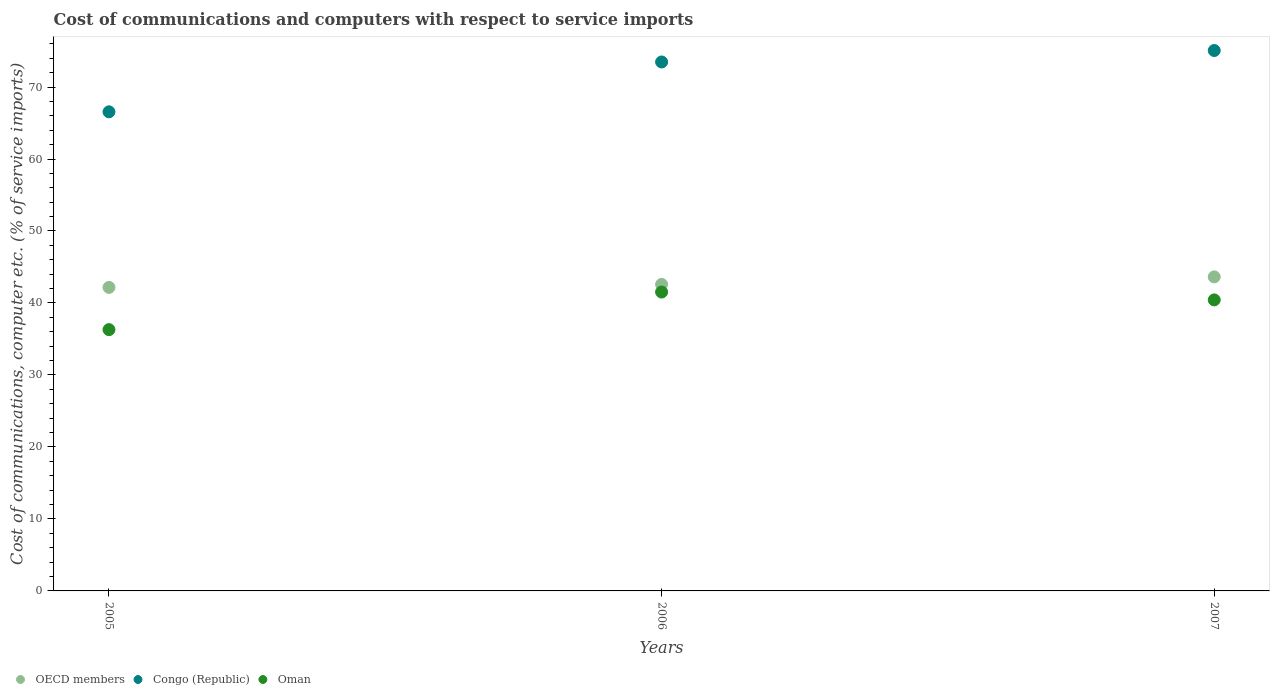How many different coloured dotlines are there?
Your answer should be very brief. 3. Is the number of dotlines equal to the number of legend labels?
Your answer should be very brief. Yes. What is the cost of communications and computers in Congo (Republic) in 2007?
Make the answer very short. 75.07. Across all years, what is the maximum cost of communications and computers in Oman?
Offer a terse response. 41.52. Across all years, what is the minimum cost of communications and computers in Oman?
Your response must be concise. 36.3. What is the total cost of communications and computers in OECD members in the graph?
Offer a terse response. 128.37. What is the difference between the cost of communications and computers in Oman in 2006 and that in 2007?
Keep it short and to the point. 1.09. What is the difference between the cost of communications and computers in Oman in 2006 and the cost of communications and computers in OECD members in 2007?
Offer a very short reply. -2.11. What is the average cost of communications and computers in OECD members per year?
Offer a terse response. 42.79. In the year 2005, what is the difference between the cost of communications and computers in Congo (Republic) and cost of communications and computers in Oman?
Your answer should be very brief. 30.26. What is the ratio of the cost of communications and computers in Congo (Republic) in 2005 to that in 2007?
Ensure brevity in your answer.  0.89. Is the cost of communications and computers in Oman in 2006 less than that in 2007?
Provide a short and direct response. No. Is the difference between the cost of communications and computers in Congo (Republic) in 2005 and 2007 greater than the difference between the cost of communications and computers in Oman in 2005 and 2007?
Offer a terse response. No. What is the difference between the highest and the second highest cost of communications and computers in OECD members?
Provide a succinct answer. 1.04. What is the difference between the highest and the lowest cost of communications and computers in Congo (Republic)?
Your answer should be compact. 8.51. Is the sum of the cost of communications and computers in Congo (Republic) in 2005 and 2007 greater than the maximum cost of communications and computers in OECD members across all years?
Give a very brief answer. Yes. Is the cost of communications and computers in OECD members strictly greater than the cost of communications and computers in Oman over the years?
Your answer should be compact. Yes. How many dotlines are there?
Your response must be concise. 3. How many years are there in the graph?
Your response must be concise. 3. Does the graph contain any zero values?
Offer a very short reply. No. Does the graph contain grids?
Make the answer very short. No. How are the legend labels stacked?
Make the answer very short. Horizontal. What is the title of the graph?
Keep it short and to the point. Cost of communications and computers with respect to service imports. What is the label or title of the X-axis?
Your response must be concise. Years. What is the label or title of the Y-axis?
Provide a short and direct response. Cost of communications, computer etc. (% of service imports). What is the Cost of communications, computer etc. (% of service imports) of OECD members in 2005?
Provide a succinct answer. 42.17. What is the Cost of communications, computer etc. (% of service imports) of Congo (Republic) in 2005?
Your answer should be compact. 66.56. What is the Cost of communications, computer etc. (% of service imports) in Oman in 2005?
Ensure brevity in your answer.  36.3. What is the Cost of communications, computer etc. (% of service imports) of OECD members in 2006?
Your answer should be very brief. 42.58. What is the Cost of communications, computer etc. (% of service imports) of Congo (Republic) in 2006?
Make the answer very short. 73.48. What is the Cost of communications, computer etc. (% of service imports) in Oman in 2006?
Your answer should be very brief. 41.52. What is the Cost of communications, computer etc. (% of service imports) in OECD members in 2007?
Provide a short and direct response. 43.63. What is the Cost of communications, computer etc. (% of service imports) of Congo (Republic) in 2007?
Your response must be concise. 75.07. What is the Cost of communications, computer etc. (% of service imports) of Oman in 2007?
Keep it short and to the point. 40.43. Across all years, what is the maximum Cost of communications, computer etc. (% of service imports) in OECD members?
Offer a terse response. 43.63. Across all years, what is the maximum Cost of communications, computer etc. (% of service imports) of Congo (Republic)?
Ensure brevity in your answer.  75.07. Across all years, what is the maximum Cost of communications, computer etc. (% of service imports) in Oman?
Provide a succinct answer. 41.52. Across all years, what is the minimum Cost of communications, computer etc. (% of service imports) of OECD members?
Your answer should be very brief. 42.17. Across all years, what is the minimum Cost of communications, computer etc. (% of service imports) in Congo (Republic)?
Your answer should be compact. 66.56. Across all years, what is the minimum Cost of communications, computer etc. (% of service imports) in Oman?
Give a very brief answer. 36.3. What is the total Cost of communications, computer etc. (% of service imports) in OECD members in the graph?
Ensure brevity in your answer.  128.37. What is the total Cost of communications, computer etc. (% of service imports) in Congo (Republic) in the graph?
Keep it short and to the point. 215.11. What is the total Cost of communications, computer etc. (% of service imports) in Oman in the graph?
Offer a terse response. 118.24. What is the difference between the Cost of communications, computer etc. (% of service imports) in OECD members in 2005 and that in 2006?
Ensure brevity in your answer.  -0.42. What is the difference between the Cost of communications, computer etc. (% of service imports) of Congo (Republic) in 2005 and that in 2006?
Give a very brief answer. -6.93. What is the difference between the Cost of communications, computer etc. (% of service imports) of Oman in 2005 and that in 2006?
Your answer should be compact. -5.22. What is the difference between the Cost of communications, computer etc. (% of service imports) of OECD members in 2005 and that in 2007?
Ensure brevity in your answer.  -1.46. What is the difference between the Cost of communications, computer etc. (% of service imports) of Congo (Republic) in 2005 and that in 2007?
Your answer should be compact. -8.51. What is the difference between the Cost of communications, computer etc. (% of service imports) in Oman in 2005 and that in 2007?
Offer a very short reply. -4.13. What is the difference between the Cost of communications, computer etc. (% of service imports) in OECD members in 2006 and that in 2007?
Make the answer very short. -1.04. What is the difference between the Cost of communications, computer etc. (% of service imports) in Congo (Republic) in 2006 and that in 2007?
Offer a very short reply. -1.59. What is the difference between the Cost of communications, computer etc. (% of service imports) of Oman in 2006 and that in 2007?
Give a very brief answer. 1.09. What is the difference between the Cost of communications, computer etc. (% of service imports) in OECD members in 2005 and the Cost of communications, computer etc. (% of service imports) in Congo (Republic) in 2006?
Ensure brevity in your answer.  -31.32. What is the difference between the Cost of communications, computer etc. (% of service imports) of OECD members in 2005 and the Cost of communications, computer etc. (% of service imports) of Oman in 2006?
Provide a succinct answer. 0.65. What is the difference between the Cost of communications, computer etc. (% of service imports) in Congo (Republic) in 2005 and the Cost of communications, computer etc. (% of service imports) in Oman in 2006?
Give a very brief answer. 25.04. What is the difference between the Cost of communications, computer etc. (% of service imports) of OECD members in 2005 and the Cost of communications, computer etc. (% of service imports) of Congo (Republic) in 2007?
Your response must be concise. -32.9. What is the difference between the Cost of communications, computer etc. (% of service imports) of OECD members in 2005 and the Cost of communications, computer etc. (% of service imports) of Oman in 2007?
Provide a short and direct response. 1.74. What is the difference between the Cost of communications, computer etc. (% of service imports) in Congo (Republic) in 2005 and the Cost of communications, computer etc. (% of service imports) in Oman in 2007?
Your answer should be compact. 26.13. What is the difference between the Cost of communications, computer etc. (% of service imports) of OECD members in 2006 and the Cost of communications, computer etc. (% of service imports) of Congo (Republic) in 2007?
Offer a terse response. -32.49. What is the difference between the Cost of communications, computer etc. (% of service imports) in OECD members in 2006 and the Cost of communications, computer etc. (% of service imports) in Oman in 2007?
Keep it short and to the point. 2.15. What is the difference between the Cost of communications, computer etc. (% of service imports) of Congo (Republic) in 2006 and the Cost of communications, computer etc. (% of service imports) of Oman in 2007?
Offer a very short reply. 33.05. What is the average Cost of communications, computer etc. (% of service imports) of OECD members per year?
Your answer should be compact. 42.79. What is the average Cost of communications, computer etc. (% of service imports) of Congo (Republic) per year?
Offer a very short reply. 71.7. What is the average Cost of communications, computer etc. (% of service imports) of Oman per year?
Your response must be concise. 39.41. In the year 2005, what is the difference between the Cost of communications, computer etc. (% of service imports) of OECD members and Cost of communications, computer etc. (% of service imports) of Congo (Republic)?
Give a very brief answer. -24.39. In the year 2005, what is the difference between the Cost of communications, computer etc. (% of service imports) of OECD members and Cost of communications, computer etc. (% of service imports) of Oman?
Ensure brevity in your answer.  5.87. In the year 2005, what is the difference between the Cost of communications, computer etc. (% of service imports) of Congo (Republic) and Cost of communications, computer etc. (% of service imports) of Oman?
Provide a short and direct response. 30.26. In the year 2006, what is the difference between the Cost of communications, computer etc. (% of service imports) of OECD members and Cost of communications, computer etc. (% of service imports) of Congo (Republic)?
Offer a very short reply. -30.9. In the year 2006, what is the difference between the Cost of communications, computer etc. (% of service imports) of OECD members and Cost of communications, computer etc. (% of service imports) of Oman?
Your response must be concise. 1.06. In the year 2006, what is the difference between the Cost of communications, computer etc. (% of service imports) in Congo (Republic) and Cost of communications, computer etc. (% of service imports) in Oman?
Your answer should be very brief. 31.96. In the year 2007, what is the difference between the Cost of communications, computer etc. (% of service imports) in OECD members and Cost of communications, computer etc. (% of service imports) in Congo (Republic)?
Provide a short and direct response. -31.44. In the year 2007, what is the difference between the Cost of communications, computer etc. (% of service imports) of OECD members and Cost of communications, computer etc. (% of service imports) of Oman?
Make the answer very short. 3.2. In the year 2007, what is the difference between the Cost of communications, computer etc. (% of service imports) of Congo (Republic) and Cost of communications, computer etc. (% of service imports) of Oman?
Provide a short and direct response. 34.64. What is the ratio of the Cost of communications, computer etc. (% of service imports) of OECD members in 2005 to that in 2006?
Keep it short and to the point. 0.99. What is the ratio of the Cost of communications, computer etc. (% of service imports) of Congo (Republic) in 2005 to that in 2006?
Your answer should be compact. 0.91. What is the ratio of the Cost of communications, computer etc. (% of service imports) in Oman in 2005 to that in 2006?
Give a very brief answer. 0.87. What is the ratio of the Cost of communications, computer etc. (% of service imports) of OECD members in 2005 to that in 2007?
Your answer should be very brief. 0.97. What is the ratio of the Cost of communications, computer etc. (% of service imports) in Congo (Republic) in 2005 to that in 2007?
Provide a succinct answer. 0.89. What is the ratio of the Cost of communications, computer etc. (% of service imports) of Oman in 2005 to that in 2007?
Offer a terse response. 0.9. What is the ratio of the Cost of communications, computer etc. (% of service imports) in OECD members in 2006 to that in 2007?
Your answer should be very brief. 0.98. What is the ratio of the Cost of communications, computer etc. (% of service imports) of Congo (Republic) in 2006 to that in 2007?
Your answer should be very brief. 0.98. What is the ratio of the Cost of communications, computer etc. (% of service imports) in Oman in 2006 to that in 2007?
Offer a very short reply. 1.03. What is the difference between the highest and the second highest Cost of communications, computer etc. (% of service imports) in OECD members?
Your response must be concise. 1.04. What is the difference between the highest and the second highest Cost of communications, computer etc. (% of service imports) in Congo (Republic)?
Your answer should be very brief. 1.59. What is the difference between the highest and the second highest Cost of communications, computer etc. (% of service imports) in Oman?
Make the answer very short. 1.09. What is the difference between the highest and the lowest Cost of communications, computer etc. (% of service imports) of OECD members?
Give a very brief answer. 1.46. What is the difference between the highest and the lowest Cost of communications, computer etc. (% of service imports) in Congo (Republic)?
Your answer should be compact. 8.51. What is the difference between the highest and the lowest Cost of communications, computer etc. (% of service imports) of Oman?
Provide a succinct answer. 5.22. 